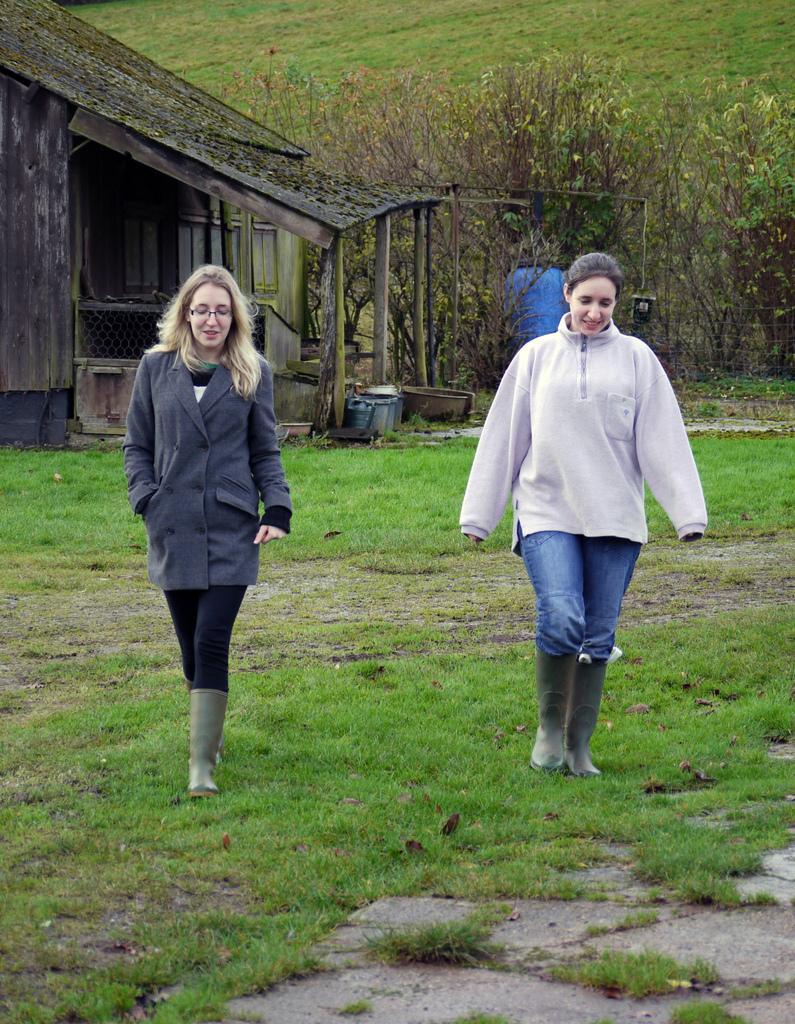In one or two sentences, can you explain what this image depicts? In this image we can see a house. There are two people walking in the image. There is a grassy land and many plants in the image. 